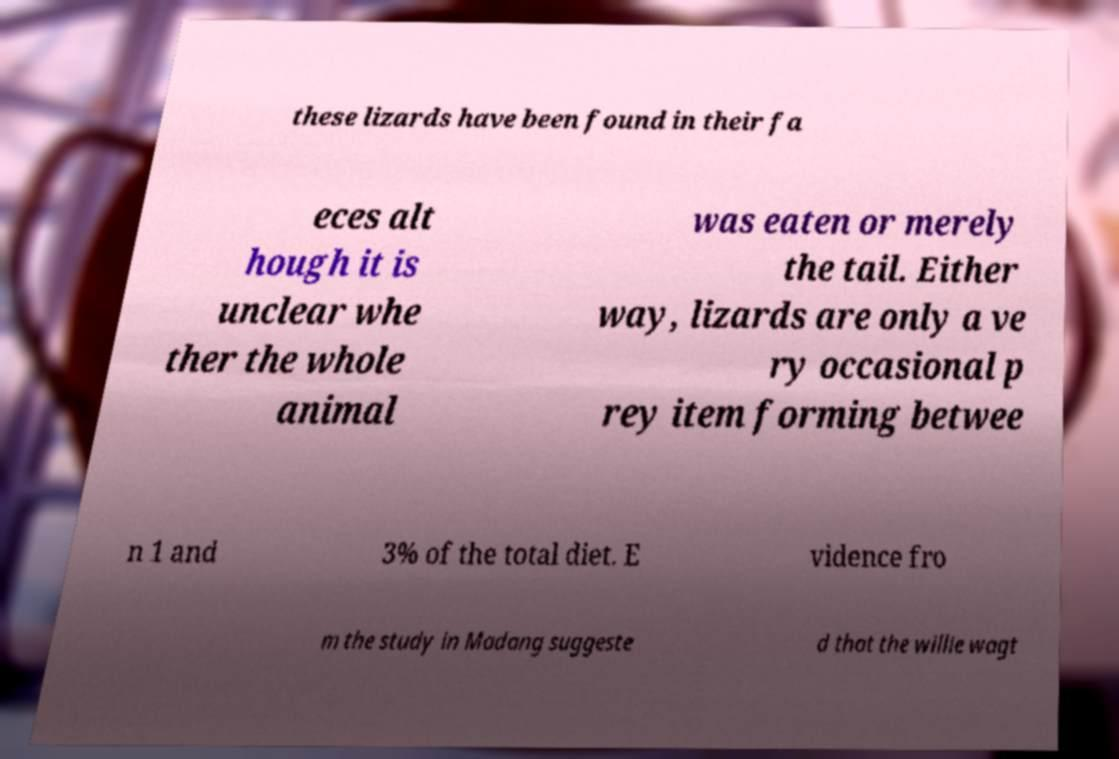There's text embedded in this image that I need extracted. Can you transcribe it verbatim? these lizards have been found in their fa eces alt hough it is unclear whe ther the whole animal was eaten or merely the tail. Either way, lizards are only a ve ry occasional p rey item forming betwee n 1 and 3% of the total diet. E vidence fro m the study in Madang suggeste d that the willie wagt 